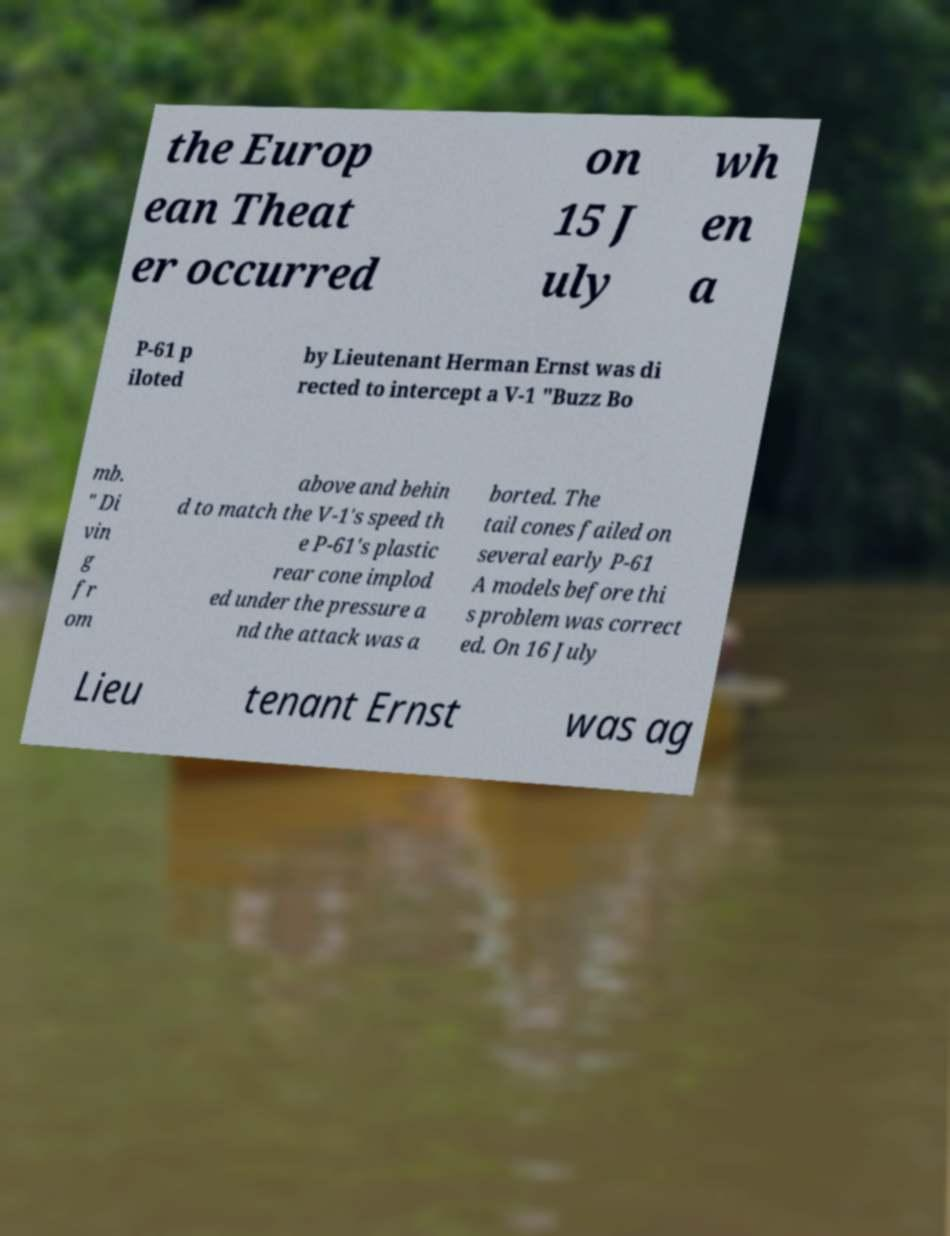What messages or text are displayed in this image? I need them in a readable, typed format. the Europ ean Theat er occurred on 15 J uly wh en a P-61 p iloted by Lieutenant Herman Ernst was di rected to intercept a V-1 "Buzz Bo mb. " Di vin g fr om above and behin d to match the V-1's speed th e P-61's plastic rear cone implod ed under the pressure a nd the attack was a borted. The tail cones failed on several early P-61 A models before thi s problem was correct ed. On 16 July Lieu tenant Ernst was ag 